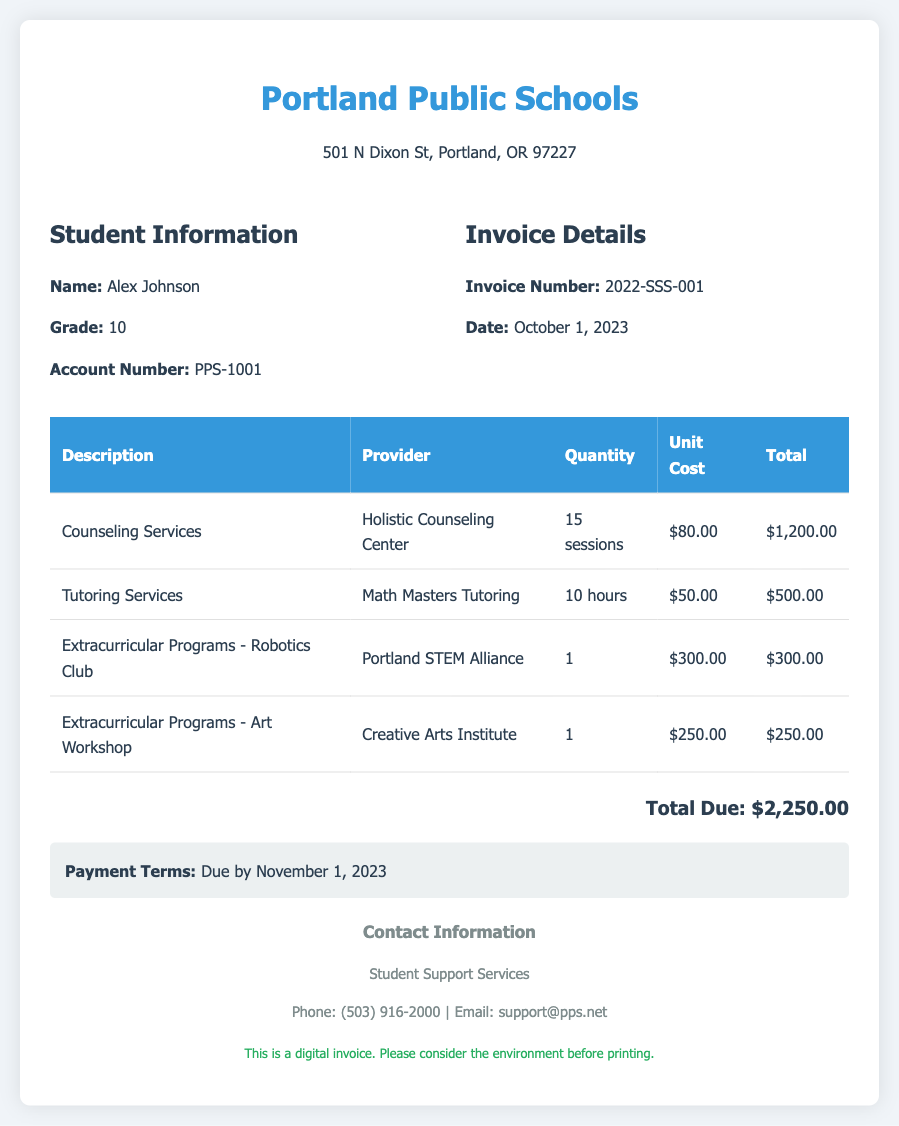What is the name of the student? The student's name is specified in the document under student information.
Answer: Alex Johnson What is the total amount due? The total amount due is calculated at the end of the document and is clearly stated.
Answer: $2,250.00 Who provided the counseling services? The document mentions the provider of the counseling services in the corresponding row.
Answer: Holistic Counseling Center How many sessions of counseling were provided? This information is available in the details of the counseling service listed in the table.
Answer: 15 sessions What is the due date for payment? The payment terms section indicates the due date for the total amount.
Answer: November 1, 2023 What was the unit cost for tutoring services? The unit cost for tutoring services is stated in the table under the tutoring service row.
Answer: $50.00 How many hours of tutoring were provided? This detail can be found in the tutoring services row of the table.
Answer: 10 hours Which organization provided the art workshop? The document specifies the provider of the art workshop in the extracurricular programs section.
Answer: Creative Arts Institute What is the invoice number? The invoice number is included in the invoice details section.
Answer: 2022-SSS-001 